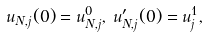Convert formula to latex. <formula><loc_0><loc_0><loc_500><loc_500>u _ { N , j } ( 0 ) = u ^ { 0 } _ { N , j } , \, u ^ { \prime } _ { N , j } ( 0 ) = u ^ { 1 } _ { j } ,</formula> 